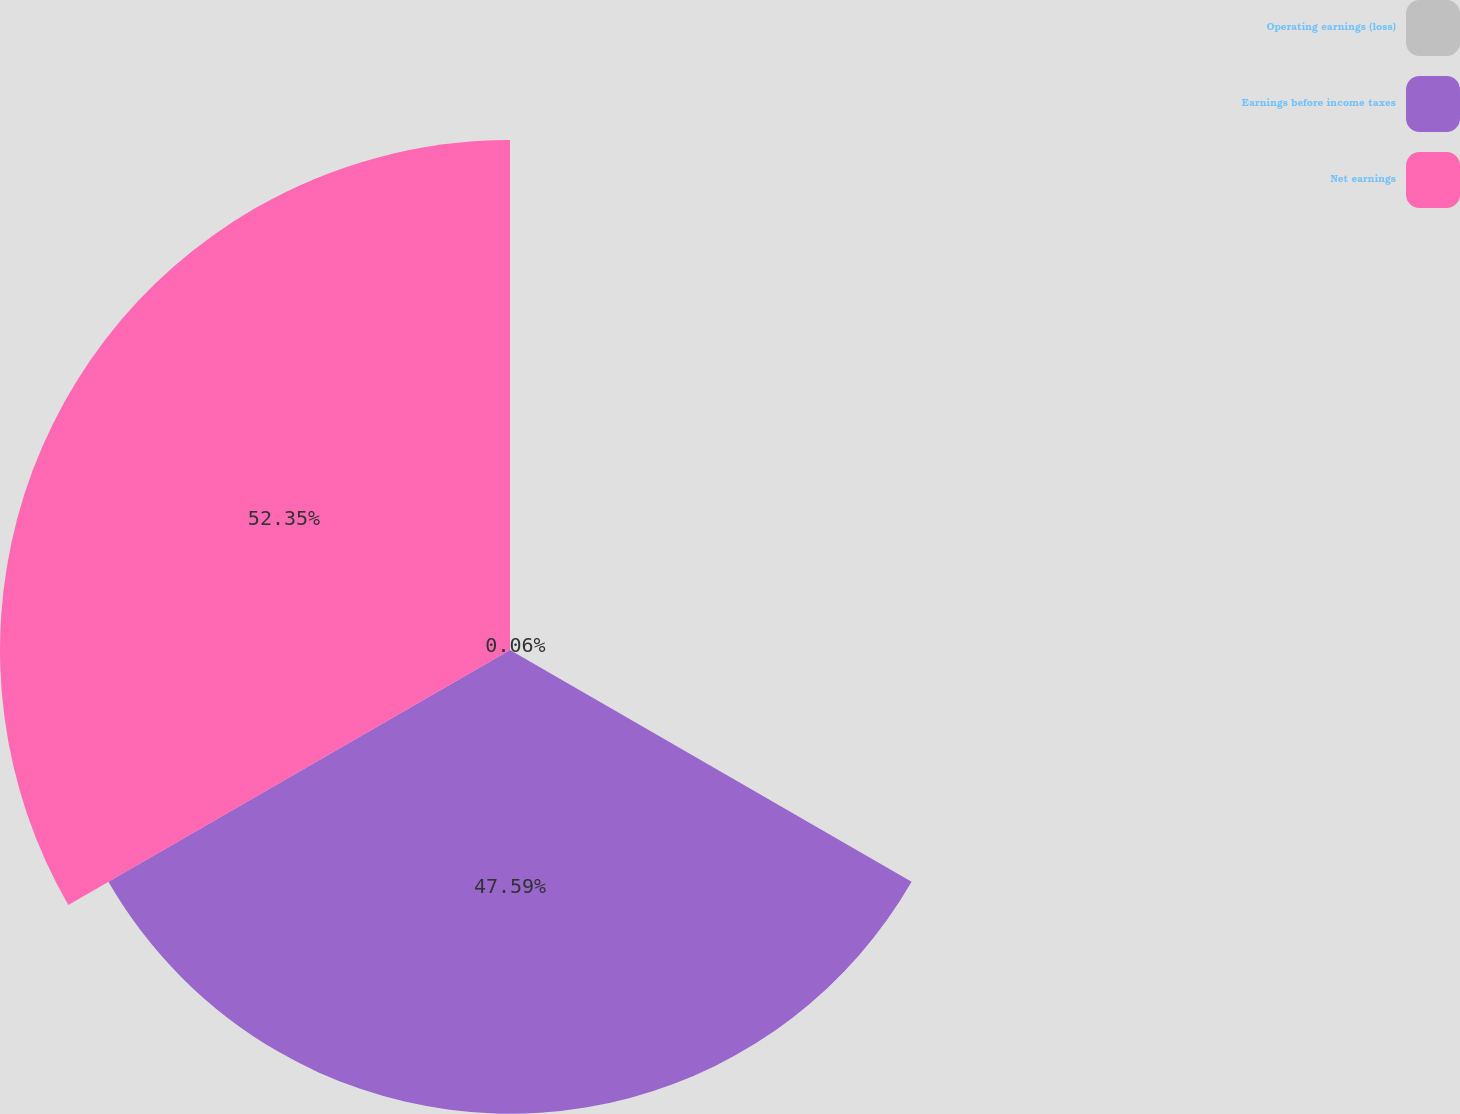Convert chart. <chart><loc_0><loc_0><loc_500><loc_500><pie_chart><fcel>Operating earnings (loss)<fcel>Earnings before income taxes<fcel>Net earnings<nl><fcel>0.06%<fcel>47.59%<fcel>52.34%<nl></chart> 